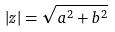<formula> <loc_0><loc_0><loc_500><loc_500>| z | = \sqrt { a ^ { 2 } + b ^ { 2 } }</formula> 